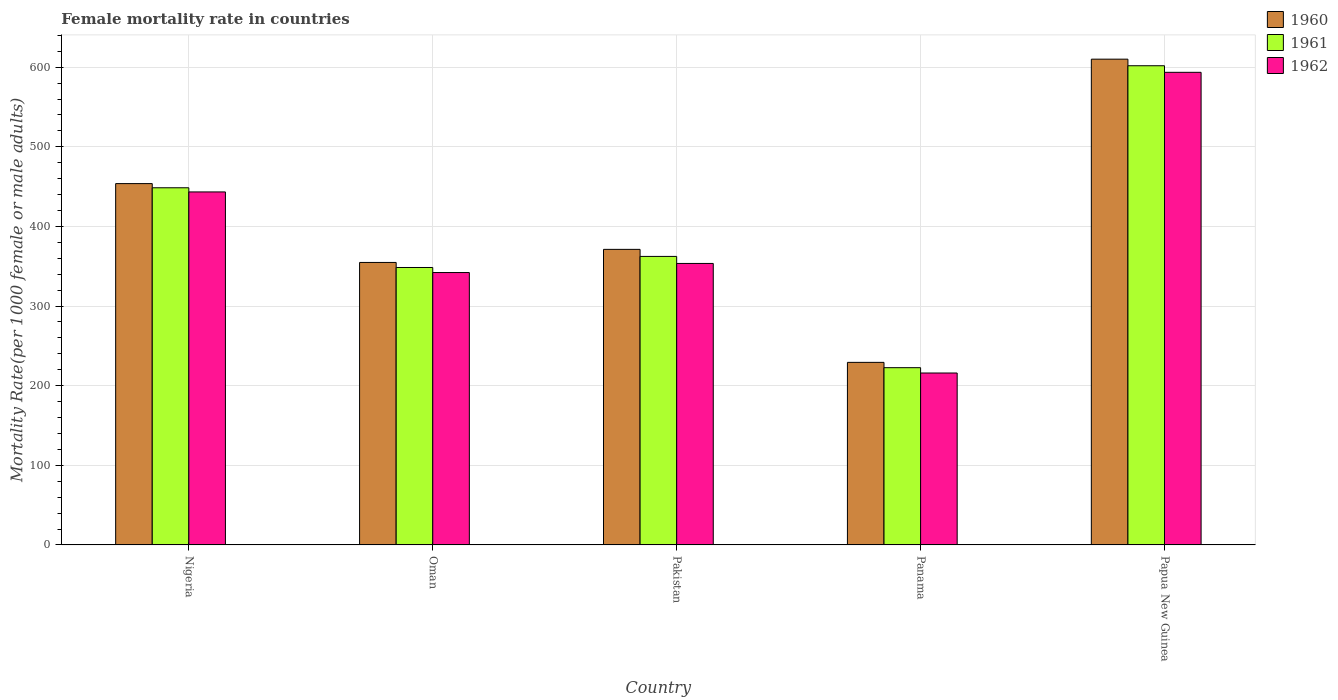How many groups of bars are there?
Your response must be concise. 5. How many bars are there on the 4th tick from the left?
Offer a terse response. 3. How many bars are there on the 5th tick from the right?
Offer a terse response. 3. What is the label of the 2nd group of bars from the left?
Keep it short and to the point. Oman. In how many cases, is the number of bars for a given country not equal to the number of legend labels?
Give a very brief answer. 0. What is the female mortality rate in 1961 in Papua New Guinea?
Your response must be concise. 601.79. Across all countries, what is the maximum female mortality rate in 1962?
Keep it short and to the point. 593.53. Across all countries, what is the minimum female mortality rate in 1960?
Offer a terse response. 229.28. In which country was the female mortality rate in 1961 maximum?
Offer a very short reply. Papua New Guinea. In which country was the female mortality rate in 1962 minimum?
Ensure brevity in your answer.  Panama. What is the total female mortality rate in 1962 in the graph?
Your response must be concise. 1948.34. What is the difference between the female mortality rate in 1961 in Panama and that in Papua New Guinea?
Offer a terse response. -379.19. What is the difference between the female mortality rate in 1960 in Panama and the female mortality rate in 1961 in Nigeria?
Your answer should be compact. -219.26. What is the average female mortality rate in 1960 per country?
Ensure brevity in your answer.  403.81. What is the difference between the female mortality rate of/in 1961 and female mortality rate of/in 1960 in Pakistan?
Your answer should be very brief. -8.84. In how many countries, is the female mortality rate in 1961 greater than 300?
Your answer should be very brief. 4. What is the ratio of the female mortality rate in 1962 in Nigeria to that in Pakistan?
Offer a very short reply. 1.25. Is the female mortality rate in 1960 in Panama less than that in Papua New Guinea?
Keep it short and to the point. Yes. What is the difference between the highest and the second highest female mortality rate in 1961?
Make the answer very short. -153.25. What is the difference between the highest and the lowest female mortality rate in 1961?
Offer a terse response. 379.19. What does the 2nd bar from the left in Oman represents?
Keep it short and to the point. 1961. What does the 3rd bar from the right in Pakistan represents?
Offer a terse response. 1960. How many bars are there?
Keep it short and to the point. 15. Are the values on the major ticks of Y-axis written in scientific E-notation?
Provide a short and direct response. No. Where does the legend appear in the graph?
Your answer should be compact. Top right. What is the title of the graph?
Keep it short and to the point. Female mortality rate in countries. What is the label or title of the Y-axis?
Ensure brevity in your answer.  Mortality Rate(per 1000 female or male adults). What is the Mortality Rate(per 1000 female or male adults) in 1960 in Nigeria?
Offer a terse response. 453.78. What is the Mortality Rate(per 1000 female or male adults) of 1961 in Nigeria?
Provide a succinct answer. 448.54. What is the Mortality Rate(per 1000 female or male adults) in 1962 in Nigeria?
Give a very brief answer. 443.31. What is the Mortality Rate(per 1000 female or male adults) in 1960 in Oman?
Keep it short and to the point. 354.76. What is the Mortality Rate(per 1000 female or male adults) in 1961 in Oman?
Offer a terse response. 348.42. What is the Mortality Rate(per 1000 female or male adults) in 1962 in Oman?
Your answer should be compact. 342.09. What is the Mortality Rate(per 1000 female or male adults) of 1960 in Pakistan?
Make the answer very short. 371.18. What is the Mortality Rate(per 1000 female or male adults) in 1961 in Pakistan?
Offer a very short reply. 362.34. What is the Mortality Rate(per 1000 female or male adults) of 1962 in Pakistan?
Provide a short and direct response. 353.5. What is the Mortality Rate(per 1000 female or male adults) in 1960 in Panama?
Provide a short and direct response. 229.28. What is the Mortality Rate(per 1000 female or male adults) of 1961 in Panama?
Keep it short and to the point. 222.6. What is the Mortality Rate(per 1000 female or male adults) in 1962 in Panama?
Your response must be concise. 215.92. What is the Mortality Rate(per 1000 female or male adults) of 1960 in Papua New Guinea?
Offer a terse response. 610.05. What is the Mortality Rate(per 1000 female or male adults) in 1961 in Papua New Guinea?
Provide a succinct answer. 601.79. What is the Mortality Rate(per 1000 female or male adults) of 1962 in Papua New Guinea?
Give a very brief answer. 593.53. Across all countries, what is the maximum Mortality Rate(per 1000 female or male adults) of 1960?
Keep it short and to the point. 610.05. Across all countries, what is the maximum Mortality Rate(per 1000 female or male adults) in 1961?
Your answer should be compact. 601.79. Across all countries, what is the maximum Mortality Rate(per 1000 female or male adults) in 1962?
Ensure brevity in your answer.  593.53. Across all countries, what is the minimum Mortality Rate(per 1000 female or male adults) in 1960?
Your response must be concise. 229.28. Across all countries, what is the minimum Mortality Rate(per 1000 female or male adults) in 1961?
Your answer should be very brief. 222.6. Across all countries, what is the minimum Mortality Rate(per 1000 female or male adults) in 1962?
Make the answer very short. 215.92. What is the total Mortality Rate(per 1000 female or male adults) of 1960 in the graph?
Your answer should be compact. 2019.04. What is the total Mortality Rate(per 1000 female or male adults) in 1961 in the graph?
Keep it short and to the point. 1983.69. What is the total Mortality Rate(per 1000 female or male adults) of 1962 in the graph?
Ensure brevity in your answer.  1948.34. What is the difference between the Mortality Rate(per 1000 female or male adults) in 1960 in Nigeria and that in Oman?
Your response must be concise. 99.02. What is the difference between the Mortality Rate(per 1000 female or male adults) in 1961 in Nigeria and that in Oman?
Your answer should be compact. 100.12. What is the difference between the Mortality Rate(per 1000 female or male adults) of 1962 in Nigeria and that in Oman?
Offer a terse response. 101.22. What is the difference between the Mortality Rate(per 1000 female or male adults) in 1960 in Nigeria and that in Pakistan?
Ensure brevity in your answer.  82.59. What is the difference between the Mortality Rate(per 1000 female or male adults) in 1961 in Nigeria and that in Pakistan?
Your answer should be very brief. 86.2. What is the difference between the Mortality Rate(per 1000 female or male adults) in 1962 in Nigeria and that in Pakistan?
Your answer should be very brief. 89.81. What is the difference between the Mortality Rate(per 1000 female or male adults) in 1960 in Nigeria and that in Panama?
Make the answer very short. 224.5. What is the difference between the Mortality Rate(per 1000 female or male adults) of 1961 in Nigeria and that in Panama?
Provide a succinct answer. 225.94. What is the difference between the Mortality Rate(per 1000 female or male adults) in 1962 in Nigeria and that in Panama?
Give a very brief answer. 227.39. What is the difference between the Mortality Rate(per 1000 female or male adults) of 1960 in Nigeria and that in Papua New Guinea?
Provide a succinct answer. -156.27. What is the difference between the Mortality Rate(per 1000 female or male adults) of 1961 in Nigeria and that in Papua New Guinea?
Keep it short and to the point. -153.25. What is the difference between the Mortality Rate(per 1000 female or male adults) in 1962 in Nigeria and that in Papua New Guinea?
Offer a very short reply. -150.22. What is the difference between the Mortality Rate(per 1000 female or male adults) of 1960 in Oman and that in Pakistan?
Ensure brevity in your answer.  -16.43. What is the difference between the Mortality Rate(per 1000 female or male adults) in 1961 in Oman and that in Pakistan?
Give a very brief answer. -13.92. What is the difference between the Mortality Rate(per 1000 female or male adults) of 1962 in Oman and that in Pakistan?
Offer a very short reply. -11.41. What is the difference between the Mortality Rate(per 1000 female or male adults) of 1960 in Oman and that in Panama?
Keep it short and to the point. 125.48. What is the difference between the Mortality Rate(per 1000 female or male adults) in 1961 in Oman and that in Panama?
Ensure brevity in your answer.  125.83. What is the difference between the Mortality Rate(per 1000 female or male adults) in 1962 in Oman and that in Panama?
Make the answer very short. 126.17. What is the difference between the Mortality Rate(per 1000 female or male adults) of 1960 in Oman and that in Papua New Guinea?
Give a very brief answer. -255.29. What is the difference between the Mortality Rate(per 1000 female or male adults) of 1961 in Oman and that in Papua New Guinea?
Give a very brief answer. -253.37. What is the difference between the Mortality Rate(per 1000 female or male adults) in 1962 in Oman and that in Papua New Guinea?
Give a very brief answer. -251.44. What is the difference between the Mortality Rate(per 1000 female or male adults) of 1960 in Pakistan and that in Panama?
Make the answer very short. 141.9. What is the difference between the Mortality Rate(per 1000 female or male adults) in 1961 in Pakistan and that in Panama?
Give a very brief answer. 139.74. What is the difference between the Mortality Rate(per 1000 female or male adults) in 1962 in Pakistan and that in Panama?
Your answer should be very brief. 137.58. What is the difference between the Mortality Rate(per 1000 female or male adults) in 1960 in Pakistan and that in Papua New Guinea?
Ensure brevity in your answer.  -238.86. What is the difference between the Mortality Rate(per 1000 female or male adults) in 1961 in Pakistan and that in Papua New Guinea?
Make the answer very short. -239.45. What is the difference between the Mortality Rate(per 1000 female or male adults) of 1962 in Pakistan and that in Papua New Guinea?
Offer a terse response. -240.03. What is the difference between the Mortality Rate(per 1000 female or male adults) in 1960 in Panama and that in Papua New Guinea?
Your answer should be very brief. -380.77. What is the difference between the Mortality Rate(per 1000 female or male adults) in 1961 in Panama and that in Papua New Guinea?
Provide a short and direct response. -379.19. What is the difference between the Mortality Rate(per 1000 female or male adults) of 1962 in Panama and that in Papua New Guinea?
Make the answer very short. -377.61. What is the difference between the Mortality Rate(per 1000 female or male adults) of 1960 in Nigeria and the Mortality Rate(per 1000 female or male adults) of 1961 in Oman?
Your response must be concise. 105.35. What is the difference between the Mortality Rate(per 1000 female or male adults) in 1960 in Nigeria and the Mortality Rate(per 1000 female or male adults) in 1962 in Oman?
Your answer should be very brief. 111.69. What is the difference between the Mortality Rate(per 1000 female or male adults) in 1961 in Nigeria and the Mortality Rate(per 1000 female or male adults) in 1962 in Oman?
Offer a terse response. 106.45. What is the difference between the Mortality Rate(per 1000 female or male adults) of 1960 in Nigeria and the Mortality Rate(per 1000 female or male adults) of 1961 in Pakistan?
Your answer should be very brief. 91.44. What is the difference between the Mortality Rate(per 1000 female or male adults) in 1960 in Nigeria and the Mortality Rate(per 1000 female or male adults) in 1962 in Pakistan?
Ensure brevity in your answer.  100.28. What is the difference between the Mortality Rate(per 1000 female or male adults) of 1961 in Nigeria and the Mortality Rate(per 1000 female or male adults) of 1962 in Pakistan?
Offer a very short reply. 95.04. What is the difference between the Mortality Rate(per 1000 female or male adults) in 1960 in Nigeria and the Mortality Rate(per 1000 female or male adults) in 1961 in Panama?
Offer a terse response. 231.18. What is the difference between the Mortality Rate(per 1000 female or male adults) of 1960 in Nigeria and the Mortality Rate(per 1000 female or male adults) of 1962 in Panama?
Ensure brevity in your answer.  237.86. What is the difference between the Mortality Rate(per 1000 female or male adults) of 1961 in Nigeria and the Mortality Rate(per 1000 female or male adults) of 1962 in Panama?
Your answer should be compact. 232.62. What is the difference between the Mortality Rate(per 1000 female or male adults) in 1960 in Nigeria and the Mortality Rate(per 1000 female or male adults) in 1961 in Papua New Guinea?
Your response must be concise. -148.01. What is the difference between the Mortality Rate(per 1000 female or male adults) of 1960 in Nigeria and the Mortality Rate(per 1000 female or male adults) of 1962 in Papua New Guinea?
Give a very brief answer. -139.75. What is the difference between the Mortality Rate(per 1000 female or male adults) of 1961 in Nigeria and the Mortality Rate(per 1000 female or male adults) of 1962 in Papua New Guinea?
Offer a very short reply. -144.99. What is the difference between the Mortality Rate(per 1000 female or male adults) in 1960 in Oman and the Mortality Rate(per 1000 female or male adults) in 1961 in Pakistan?
Your answer should be compact. -7.58. What is the difference between the Mortality Rate(per 1000 female or male adults) of 1960 in Oman and the Mortality Rate(per 1000 female or male adults) of 1962 in Pakistan?
Ensure brevity in your answer.  1.26. What is the difference between the Mortality Rate(per 1000 female or male adults) of 1961 in Oman and the Mortality Rate(per 1000 female or male adults) of 1962 in Pakistan?
Provide a short and direct response. -5.07. What is the difference between the Mortality Rate(per 1000 female or male adults) of 1960 in Oman and the Mortality Rate(per 1000 female or male adults) of 1961 in Panama?
Provide a succinct answer. 132.16. What is the difference between the Mortality Rate(per 1000 female or male adults) in 1960 in Oman and the Mortality Rate(per 1000 female or male adults) in 1962 in Panama?
Provide a short and direct response. 138.84. What is the difference between the Mortality Rate(per 1000 female or male adults) in 1961 in Oman and the Mortality Rate(per 1000 female or male adults) in 1962 in Panama?
Your answer should be compact. 132.51. What is the difference between the Mortality Rate(per 1000 female or male adults) of 1960 in Oman and the Mortality Rate(per 1000 female or male adults) of 1961 in Papua New Guinea?
Offer a terse response. -247.03. What is the difference between the Mortality Rate(per 1000 female or male adults) in 1960 in Oman and the Mortality Rate(per 1000 female or male adults) in 1962 in Papua New Guinea?
Ensure brevity in your answer.  -238.77. What is the difference between the Mortality Rate(per 1000 female or male adults) in 1961 in Oman and the Mortality Rate(per 1000 female or male adults) in 1962 in Papua New Guinea?
Your response must be concise. -245.11. What is the difference between the Mortality Rate(per 1000 female or male adults) in 1960 in Pakistan and the Mortality Rate(per 1000 female or male adults) in 1961 in Panama?
Your answer should be compact. 148.58. What is the difference between the Mortality Rate(per 1000 female or male adults) of 1960 in Pakistan and the Mortality Rate(per 1000 female or male adults) of 1962 in Panama?
Provide a succinct answer. 155.26. What is the difference between the Mortality Rate(per 1000 female or male adults) in 1961 in Pakistan and the Mortality Rate(per 1000 female or male adults) in 1962 in Panama?
Make the answer very short. 146.42. What is the difference between the Mortality Rate(per 1000 female or male adults) of 1960 in Pakistan and the Mortality Rate(per 1000 female or male adults) of 1961 in Papua New Guinea?
Your answer should be very brief. -230.61. What is the difference between the Mortality Rate(per 1000 female or male adults) of 1960 in Pakistan and the Mortality Rate(per 1000 female or male adults) of 1962 in Papua New Guinea?
Offer a terse response. -222.35. What is the difference between the Mortality Rate(per 1000 female or male adults) in 1961 in Pakistan and the Mortality Rate(per 1000 female or male adults) in 1962 in Papua New Guinea?
Your answer should be very brief. -231.19. What is the difference between the Mortality Rate(per 1000 female or male adults) in 1960 in Panama and the Mortality Rate(per 1000 female or male adults) in 1961 in Papua New Guinea?
Provide a succinct answer. -372.51. What is the difference between the Mortality Rate(per 1000 female or male adults) of 1960 in Panama and the Mortality Rate(per 1000 female or male adults) of 1962 in Papua New Guinea?
Your answer should be very brief. -364.25. What is the difference between the Mortality Rate(per 1000 female or male adults) of 1961 in Panama and the Mortality Rate(per 1000 female or male adults) of 1962 in Papua New Guinea?
Your answer should be compact. -370.93. What is the average Mortality Rate(per 1000 female or male adults) of 1960 per country?
Your answer should be very brief. 403.81. What is the average Mortality Rate(per 1000 female or male adults) of 1961 per country?
Offer a very short reply. 396.74. What is the average Mortality Rate(per 1000 female or male adults) of 1962 per country?
Offer a very short reply. 389.67. What is the difference between the Mortality Rate(per 1000 female or male adults) in 1960 and Mortality Rate(per 1000 female or male adults) in 1961 in Nigeria?
Offer a very short reply. 5.24. What is the difference between the Mortality Rate(per 1000 female or male adults) in 1960 and Mortality Rate(per 1000 female or male adults) in 1962 in Nigeria?
Give a very brief answer. 10.47. What is the difference between the Mortality Rate(per 1000 female or male adults) in 1961 and Mortality Rate(per 1000 female or male adults) in 1962 in Nigeria?
Provide a short and direct response. 5.24. What is the difference between the Mortality Rate(per 1000 female or male adults) in 1960 and Mortality Rate(per 1000 female or male adults) in 1961 in Oman?
Offer a terse response. 6.33. What is the difference between the Mortality Rate(per 1000 female or male adults) of 1960 and Mortality Rate(per 1000 female or male adults) of 1962 in Oman?
Keep it short and to the point. 12.67. What is the difference between the Mortality Rate(per 1000 female or male adults) in 1961 and Mortality Rate(per 1000 female or male adults) in 1962 in Oman?
Provide a short and direct response. 6.33. What is the difference between the Mortality Rate(per 1000 female or male adults) of 1960 and Mortality Rate(per 1000 female or male adults) of 1961 in Pakistan?
Provide a succinct answer. 8.84. What is the difference between the Mortality Rate(per 1000 female or male adults) in 1960 and Mortality Rate(per 1000 female or male adults) in 1962 in Pakistan?
Ensure brevity in your answer.  17.68. What is the difference between the Mortality Rate(per 1000 female or male adults) of 1961 and Mortality Rate(per 1000 female or male adults) of 1962 in Pakistan?
Ensure brevity in your answer.  8.84. What is the difference between the Mortality Rate(per 1000 female or male adults) in 1960 and Mortality Rate(per 1000 female or male adults) in 1961 in Panama?
Your answer should be compact. 6.68. What is the difference between the Mortality Rate(per 1000 female or male adults) in 1960 and Mortality Rate(per 1000 female or male adults) in 1962 in Panama?
Provide a succinct answer. 13.36. What is the difference between the Mortality Rate(per 1000 female or male adults) in 1961 and Mortality Rate(per 1000 female or male adults) in 1962 in Panama?
Provide a succinct answer. 6.68. What is the difference between the Mortality Rate(per 1000 female or male adults) of 1960 and Mortality Rate(per 1000 female or male adults) of 1961 in Papua New Guinea?
Your answer should be compact. 8.26. What is the difference between the Mortality Rate(per 1000 female or male adults) in 1960 and Mortality Rate(per 1000 female or male adults) in 1962 in Papua New Guinea?
Your response must be concise. 16.52. What is the difference between the Mortality Rate(per 1000 female or male adults) in 1961 and Mortality Rate(per 1000 female or male adults) in 1962 in Papua New Guinea?
Ensure brevity in your answer.  8.26. What is the ratio of the Mortality Rate(per 1000 female or male adults) of 1960 in Nigeria to that in Oman?
Make the answer very short. 1.28. What is the ratio of the Mortality Rate(per 1000 female or male adults) in 1961 in Nigeria to that in Oman?
Give a very brief answer. 1.29. What is the ratio of the Mortality Rate(per 1000 female or male adults) of 1962 in Nigeria to that in Oman?
Give a very brief answer. 1.3. What is the ratio of the Mortality Rate(per 1000 female or male adults) of 1960 in Nigeria to that in Pakistan?
Offer a very short reply. 1.22. What is the ratio of the Mortality Rate(per 1000 female or male adults) in 1961 in Nigeria to that in Pakistan?
Your answer should be compact. 1.24. What is the ratio of the Mortality Rate(per 1000 female or male adults) in 1962 in Nigeria to that in Pakistan?
Offer a very short reply. 1.25. What is the ratio of the Mortality Rate(per 1000 female or male adults) in 1960 in Nigeria to that in Panama?
Keep it short and to the point. 1.98. What is the ratio of the Mortality Rate(per 1000 female or male adults) of 1961 in Nigeria to that in Panama?
Make the answer very short. 2.02. What is the ratio of the Mortality Rate(per 1000 female or male adults) of 1962 in Nigeria to that in Panama?
Make the answer very short. 2.05. What is the ratio of the Mortality Rate(per 1000 female or male adults) of 1960 in Nigeria to that in Papua New Guinea?
Ensure brevity in your answer.  0.74. What is the ratio of the Mortality Rate(per 1000 female or male adults) of 1961 in Nigeria to that in Papua New Guinea?
Offer a very short reply. 0.75. What is the ratio of the Mortality Rate(per 1000 female or male adults) of 1962 in Nigeria to that in Papua New Guinea?
Your answer should be compact. 0.75. What is the ratio of the Mortality Rate(per 1000 female or male adults) in 1960 in Oman to that in Pakistan?
Give a very brief answer. 0.96. What is the ratio of the Mortality Rate(per 1000 female or male adults) in 1961 in Oman to that in Pakistan?
Provide a succinct answer. 0.96. What is the ratio of the Mortality Rate(per 1000 female or male adults) in 1960 in Oman to that in Panama?
Your answer should be compact. 1.55. What is the ratio of the Mortality Rate(per 1000 female or male adults) of 1961 in Oman to that in Panama?
Keep it short and to the point. 1.57. What is the ratio of the Mortality Rate(per 1000 female or male adults) in 1962 in Oman to that in Panama?
Your answer should be compact. 1.58. What is the ratio of the Mortality Rate(per 1000 female or male adults) in 1960 in Oman to that in Papua New Guinea?
Offer a very short reply. 0.58. What is the ratio of the Mortality Rate(per 1000 female or male adults) of 1961 in Oman to that in Papua New Guinea?
Provide a short and direct response. 0.58. What is the ratio of the Mortality Rate(per 1000 female or male adults) of 1962 in Oman to that in Papua New Guinea?
Offer a very short reply. 0.58. What is the ratio of the Mortality Rate(per 1000 female or male adults) of 1960 in Pakistan to that in Panama?
Your answer should be compact. 1.62. What is the ratio of the Mortality Rate(per 1000 female or male adults) in 1961 in Pakistan to that in Panama?
Offer a terse response. 1.63. What is the ratio of the Mortality Rate(per 1000 female or male adults) in 1962 in Pakistan to that in Panama?
Provide a short and direct response. 1.64. What is the ratio of the Mortality Rate(per 1000 female or male adults) in 1960 in Pakistan to that in Papua New Guinea?
Your response must be concise. 0.61. What is the ratio of the Mortality Rate(per 1000 female or male adults) of 1961 in Pakistan to that in Papua New Guinea?
Make the answer very short. 0.6. What is the ratio of the Mortality Rate(per 1000 female or male adults) of 1962 in Pakistan to that in Papua New Guinea?
Give a very brief answer. 0.6. What is the ratio of the Mortality Rate(per 1000 female or male adults) in 1960 in Panama to that in Papua New Guinea?
Provide a short and direct response. 0.38. What is the ratio of the Mortality Rate(per 1000 female or male adults) in 1961 in Panama to that in Papua New Guinea?
Your answer should be very brief. 0.37. What is the ratio of the Mortality Rate(per 1000 female or male adults) in 1962 in Panama to that in Papua New Guinea?
Your answer should be very brief. 0.36. What is the difference between the highest and the second highest Mortality Rate(per 1000 female or male adults) in 1960?
Your response must be concise. 156.27. What is the difference between the highest and the second highest Mortality Rate(per 1000 female or male adults) of 1961?
Keep it short and to the point. 153.25. What is the difference between the highest and the second highest Mortality Rate(per 1000 female or male adults) in 1962?
Your answer should be very brief. 150.22. What is the difference between the highest and the lowest Mortality Rate(per 1000 female or male adults) in 1960?
Keep it short and to the point. 380.77. What is the difference between the highest and the lowest Mortality Rate(per 1000 female or male adults) of 1961?
Ensure brevity in your answer.  379.19. What is the difference between the highest and the lowest Mortality Rate(per 1000 female or male adults) of 1962?
Make the answer very short. 377.61. 